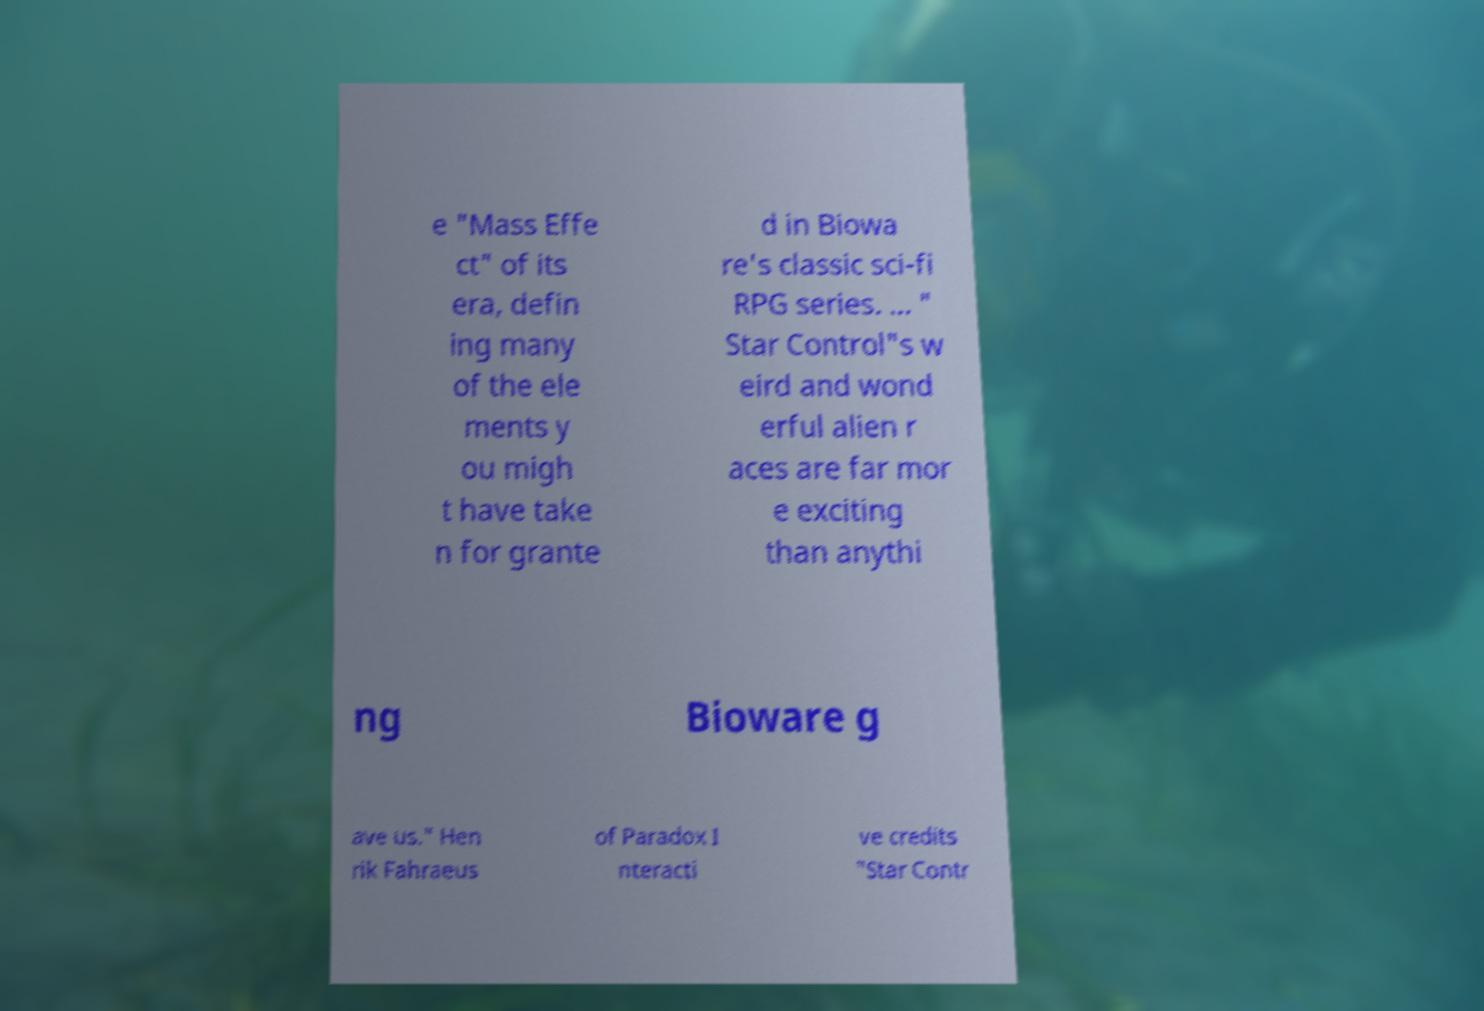Can you read and provide the text displayed in the image?This photo seems to have some interesting text. Can you extract and type it out for me? e "Mass Effe ct" of its era, defin ing many of the ele ments y ou migh t have take n for grante d in Biowa re's classic sci-fi RPG series. ... " Star Control"s w eird and wond erful alien r aces are far mor e exciting than anythi ng Bioware g ave us." Hen rik Fahraeus of Paradox I nteracti ve credits "Star Contr 